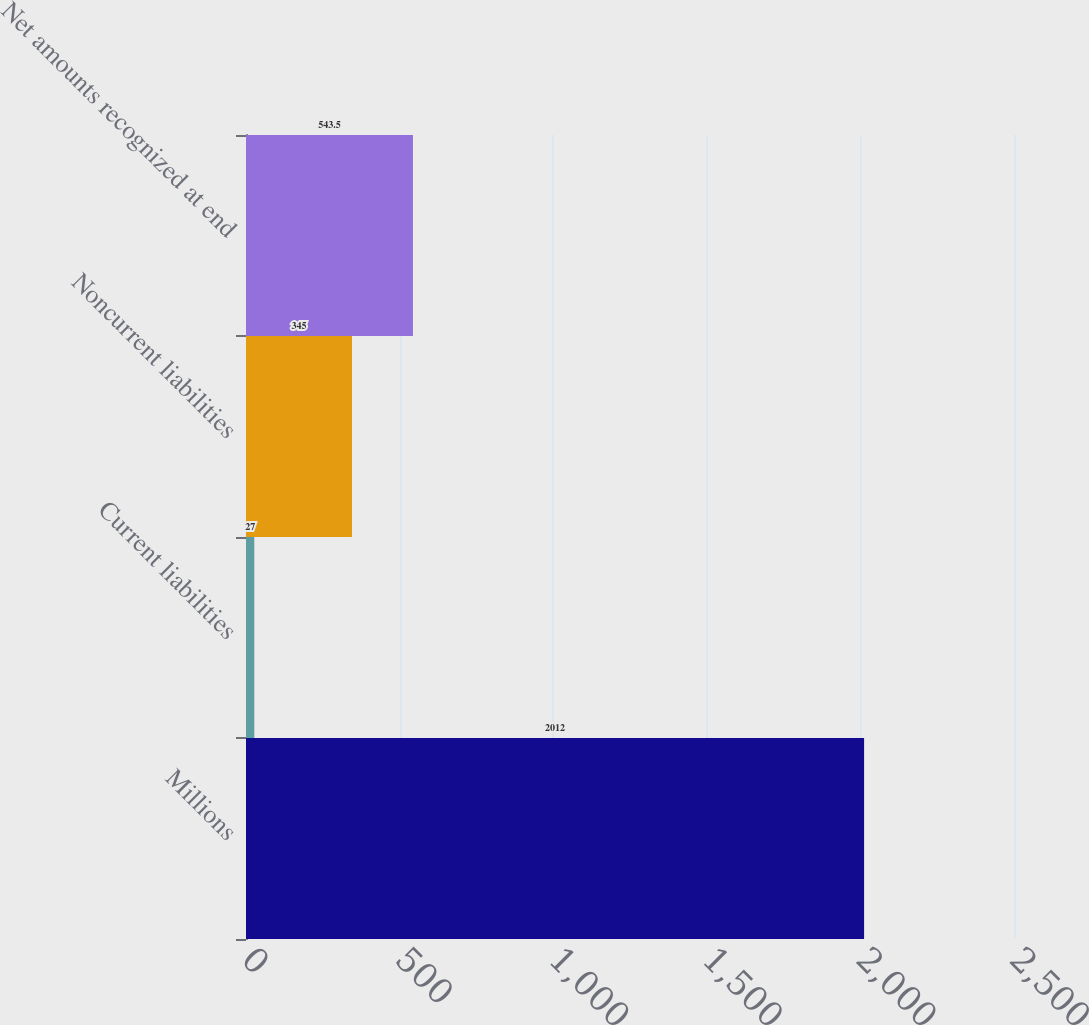Convert chart to OTSL. <chart><loc_0><loc_0><loc_500><loc_500><bar_chart><fcel>Millions<fcel>Current liabilities<fcel>Noncurrent liabilities<fcel>Net amounts recognized at end<nl><fcel>2012<fcel>27<fcel>345<fcel>543.5<nl></chart> 